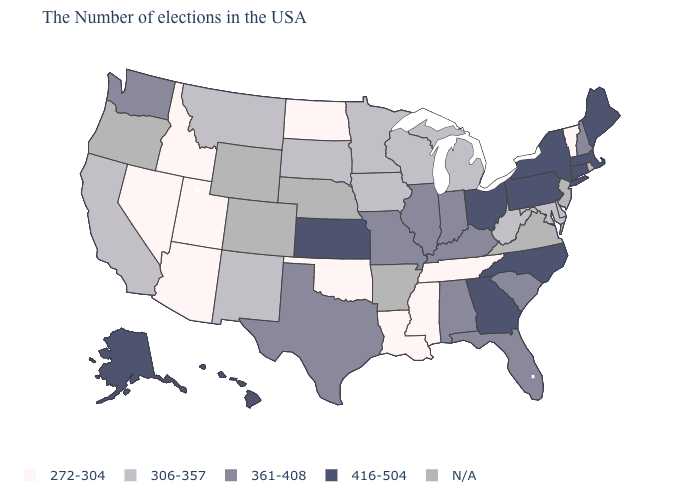What is the lowest value in the South?
Answer briefly. 272-304. Name the states that have a value in the range N/A?
Keep it brief. Rhode Island, New Jersey, Virginia, Arkansas, Nebraska, Wyoming, Colorado, Oregon. Name the states that have a value in the range 306-357?
Concise answer only. Delaware, Maryland, West Virginia, Michigan, Wisconsin, Minnesota, Iowa, South Dakota, New Mexico, Montana, California. How many symbols are there in the legend?
Quick response, please. 5. Which states have the lowest value in the Northeast?
Write a very short answer. Vermont. Name the states that have a value in the range 272-304?
Answer briefly. Vermont, Tennessee, Mississippi, Louisiana, Oklahoma, North Dakota, Utah, Arizona, Idaho, Nevada. Does the map have missing data?
Short answer required. Yes. Does Oklahoma have the lowest value in the South?
Give a very brief answer. Yes. What is the lowest value in the MidWest?
Be succinct. 272-304. What is the value of Maine?
Short answer required. 416-504. Among the states that border Florida , does Alabama have the highest value?
Answer briefly. No. Which states have the lowest value in the USA?
Concise answer only. Vermont, Tennessee, Mississippi, Louisiana, Oklahoma, North Dakota, Utah, Arizona, Idaho, Nevada. Among the states that border Montana , which have the lowest value?
Answer briefly. North Dakota, Idaho. What is the highest value in the MidWest ?
Quick response, please. 416-504. Does Vermont have the lowest value in the USA?
Short answer required. Yes. 